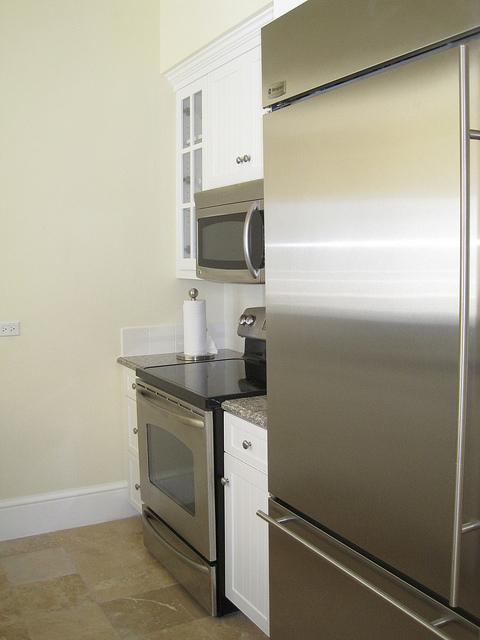Is this room clean?
Write a very short answer. Yes. What color is the stove?
Answer briefly. Silver. Where is the fridge?
Quick response, please. Kitchen. 